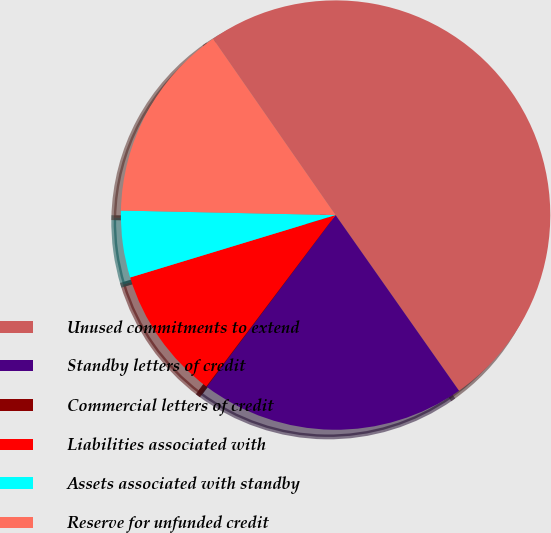Convert chart to OTSL. <chart><loc_0><loc_0><loc_500><loc_500><pie_chart><fcel>Unused commitments to extend<fcel>Standby letters of credit<fcel>Commercial letters of credit<fcel>Liabilities associated with<fcel>Assets associated with standby<fcel>Reserve for unfunded credit<nl><fcel>49.91%<fcel>19.99%<fcel>0.04%<fcel>10.02%<fcel>5.03%<fcel>15.0%<nl></chart> 